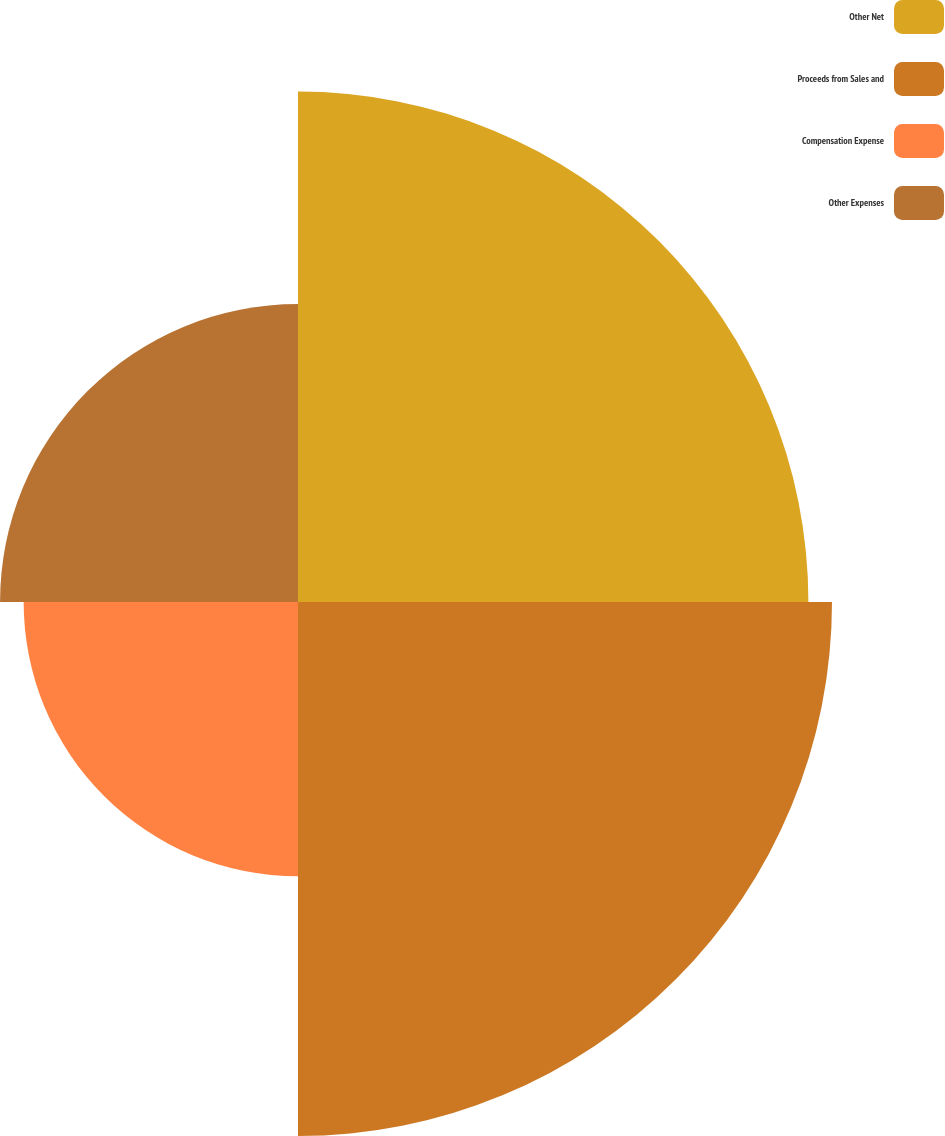<chart> <loc_0><loc_0><loc_500><loc_500><pie_chart><fcel>Other Net<fcel>Proceeds from Sales and<fcel>Compensation Expense<fcel>Other Expenses<nl><fcel>31.57%<fcel>33.03%<fcel>16.97%<fcel>18.43%<nl></chart> 